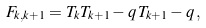<formula> <loc_0><loc_0><loc_500><loc_500>F _ { k , k + 1 } = T _ { k } T _ { k + 1 } - q \, T _ { k + 1 } - q \, ,</formula> 